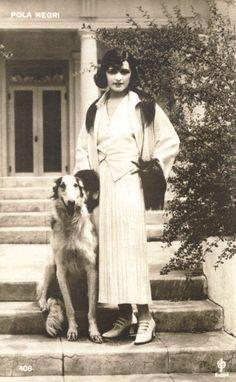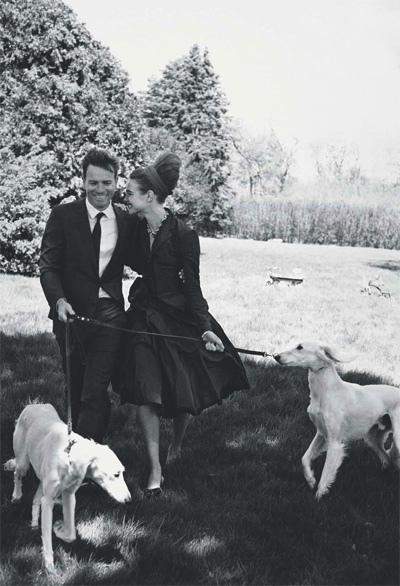The first image is the image on the left, the second image is the image on the right. Given the left and right images, does the statement "In one image, afghans are on leashes, and a man is on the left of a woman in a blowing skirt." hold true? Answer yes or no. Yes. The first image is the image on the left, the second image is the image on the right. For the images shown, is this caption "There are three people and three dogs." true? Answer yes or no. Yes. 